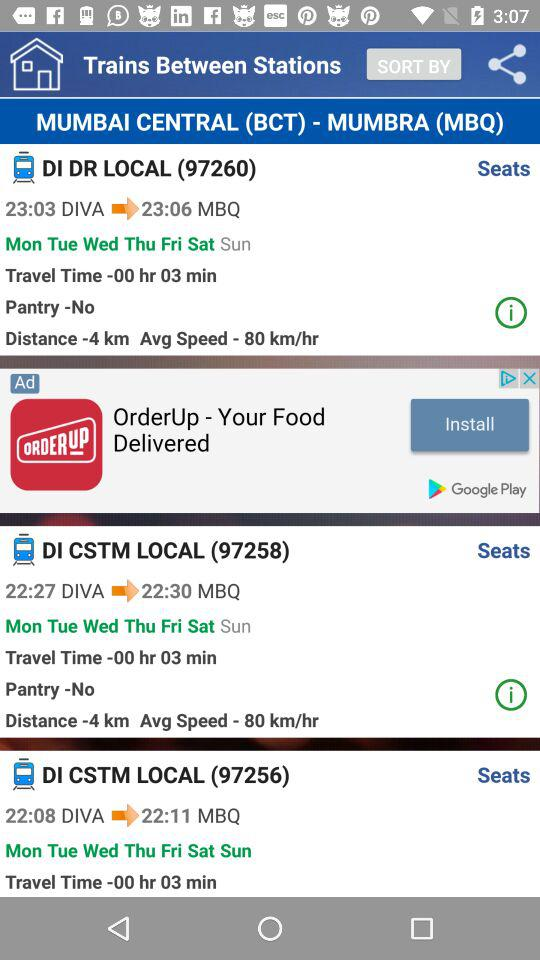What train has train number 97256? The train that has train number 97256 is DI CSTM LOCAL. 